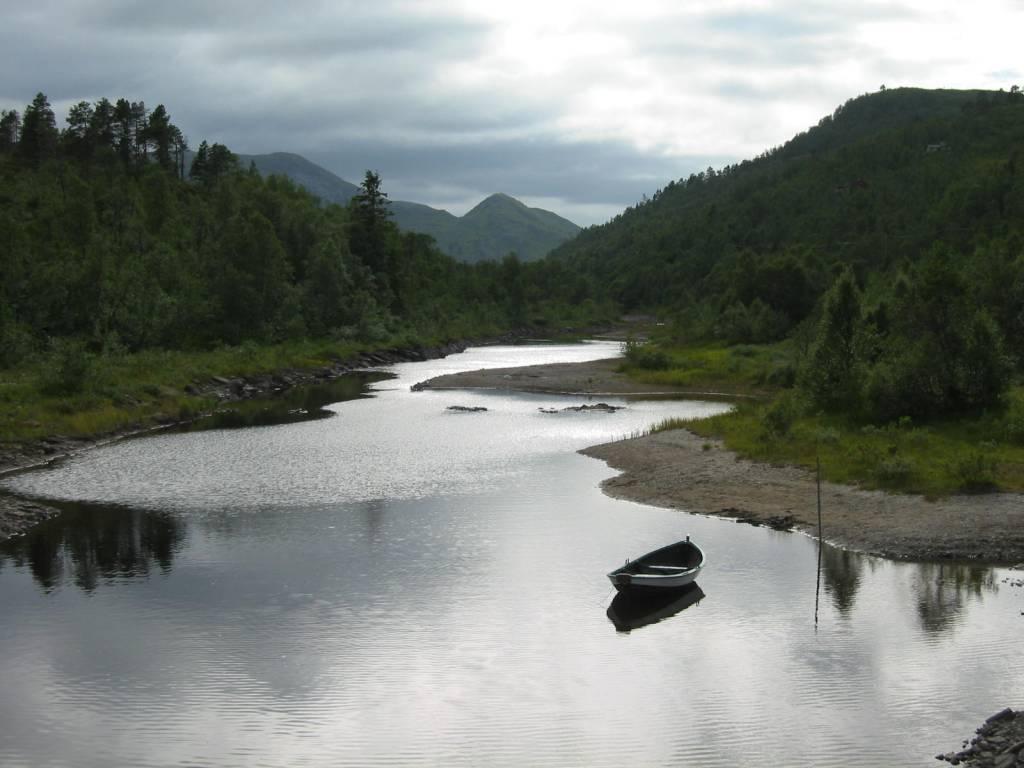Could you give a brief overview of what you see in this image? In this picture we can see water at the bottom, there is a boat in the water, in the background there are some trees and plants, there is the sky and clouds at the top of the picture. 